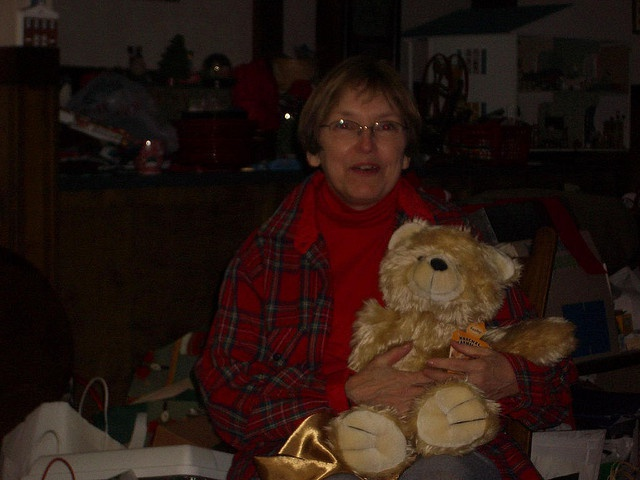Describe the objects in this image and their specific colors. I can see people in black, maroon, and gray tones, teddy bear in black, maroon, and gray tones, and handbag in black and gray tones in this image. 